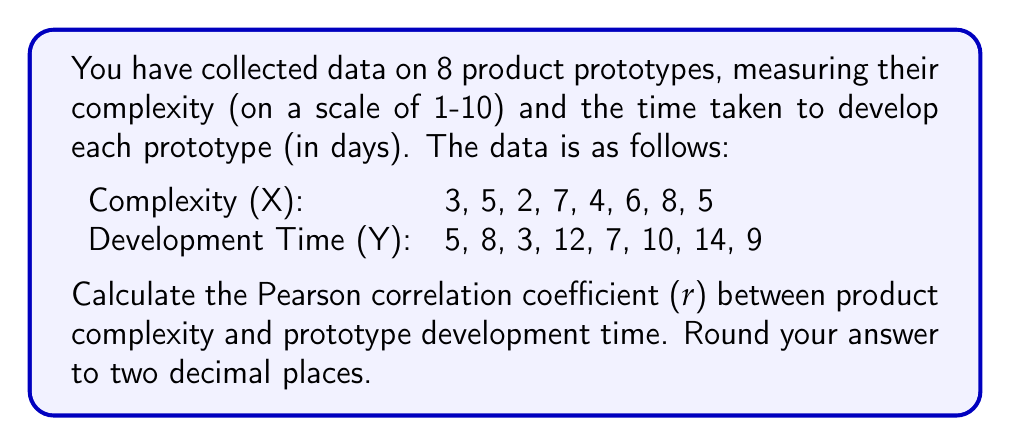Solve this math problem. To calculate the Pearson correlation coefficient (r), we'll follow these steps:

1. Calculate the means of X and Y:
   $$\bar{X} = \frac{\sum X}{n} = \frac{3+5+2+7+4+6+8+5}{8} = 5$$
   $$\bar{Y} = \frac{\sum Y}{n} = \frac{5+8+3+12+7+10+14+9}{8} = 8.5$$

2. Calculate the deviations from the mean for X and Y:
   X - X̄: -2, 0, -3, 2, -1, 1, 3, 0
   Y - Ȳ: -3.5, -0.5, -5.5, 3.5, -1.5, 1.5, 5.5, 0.5

3. Calculate the products of the deviations:
   (X - X̄)(Y - Ȳ): 7, 0, 16.5, 7, 1.5, 1.5, 16.5, 0

4. Calculate the squares of the deviations:
   (X - X̄)²: 4, 0, 9, 4, 1, 1, 9, 0
   (Y - Ȳ)²: 12.25, 0.25, 30.25, 12.25, 2.25, 2.25, 30.25, 0.25

5. Sum up the results:
   $$\sum(X - \bar{X})(Y - \bar{Y}) = 50$$
   $$\sum(X - \bar{X})^2 = 28$$
   $$\sum(Y - \bar{Y})^2 = 90$$

6. Apply the Pearson correlation coefficient formula:
   $$r = \frac{\sum(X - \bar{X})(Y - \bar{Y})}{\sqrt{\sum(X - \bar{X})^2 \sum(Y - \bar{Y})^2}}$$

   $$r = \frac{50}{\sqrt{28 \times 90}} = \frac{50}{\sqrt{2520}} = \frac{50}{50.20} = 0.9960$$

7. Round to two decimal places: 1.00
Answer: 1.00 